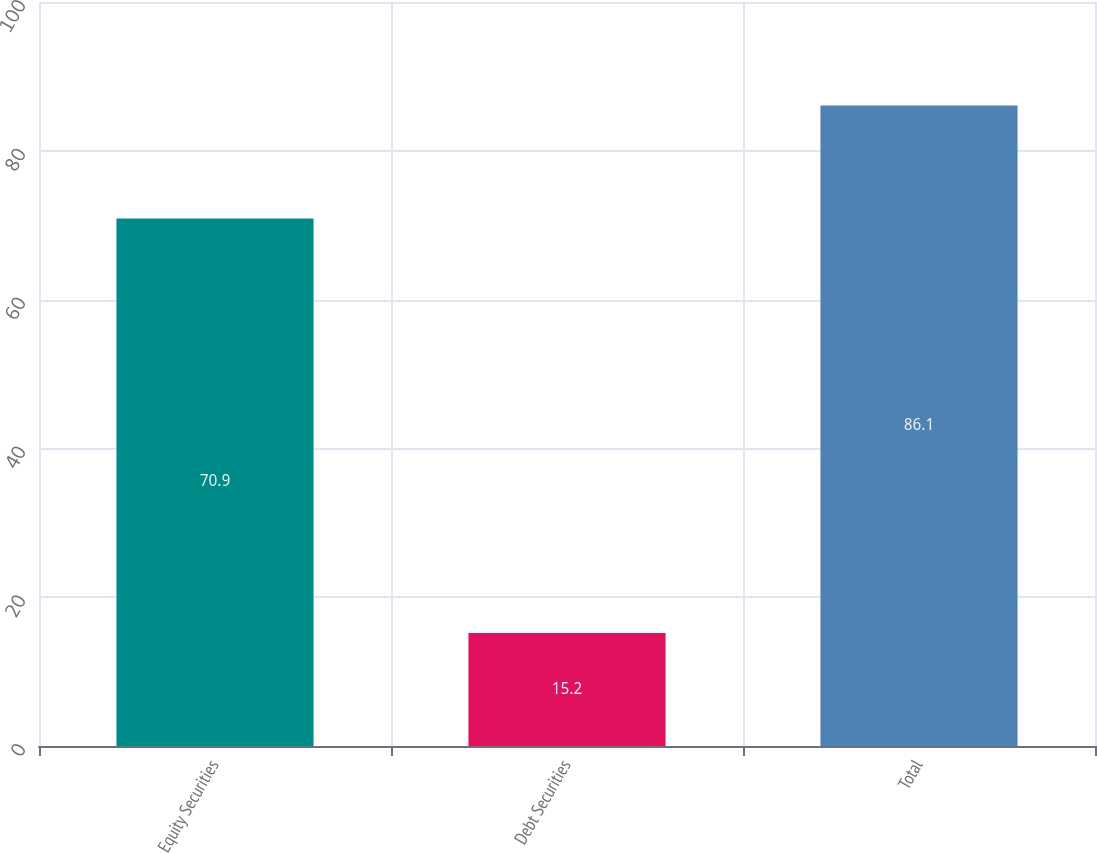<chart> <loc_0><loc_0><loc_500><loc_500><bar_chart><fcel>Equity Securities<fcel>Debt Securities<fcel>Total<nl><fcel>70.9<fcel>15.2<fcel>86.1<nl></chart> 